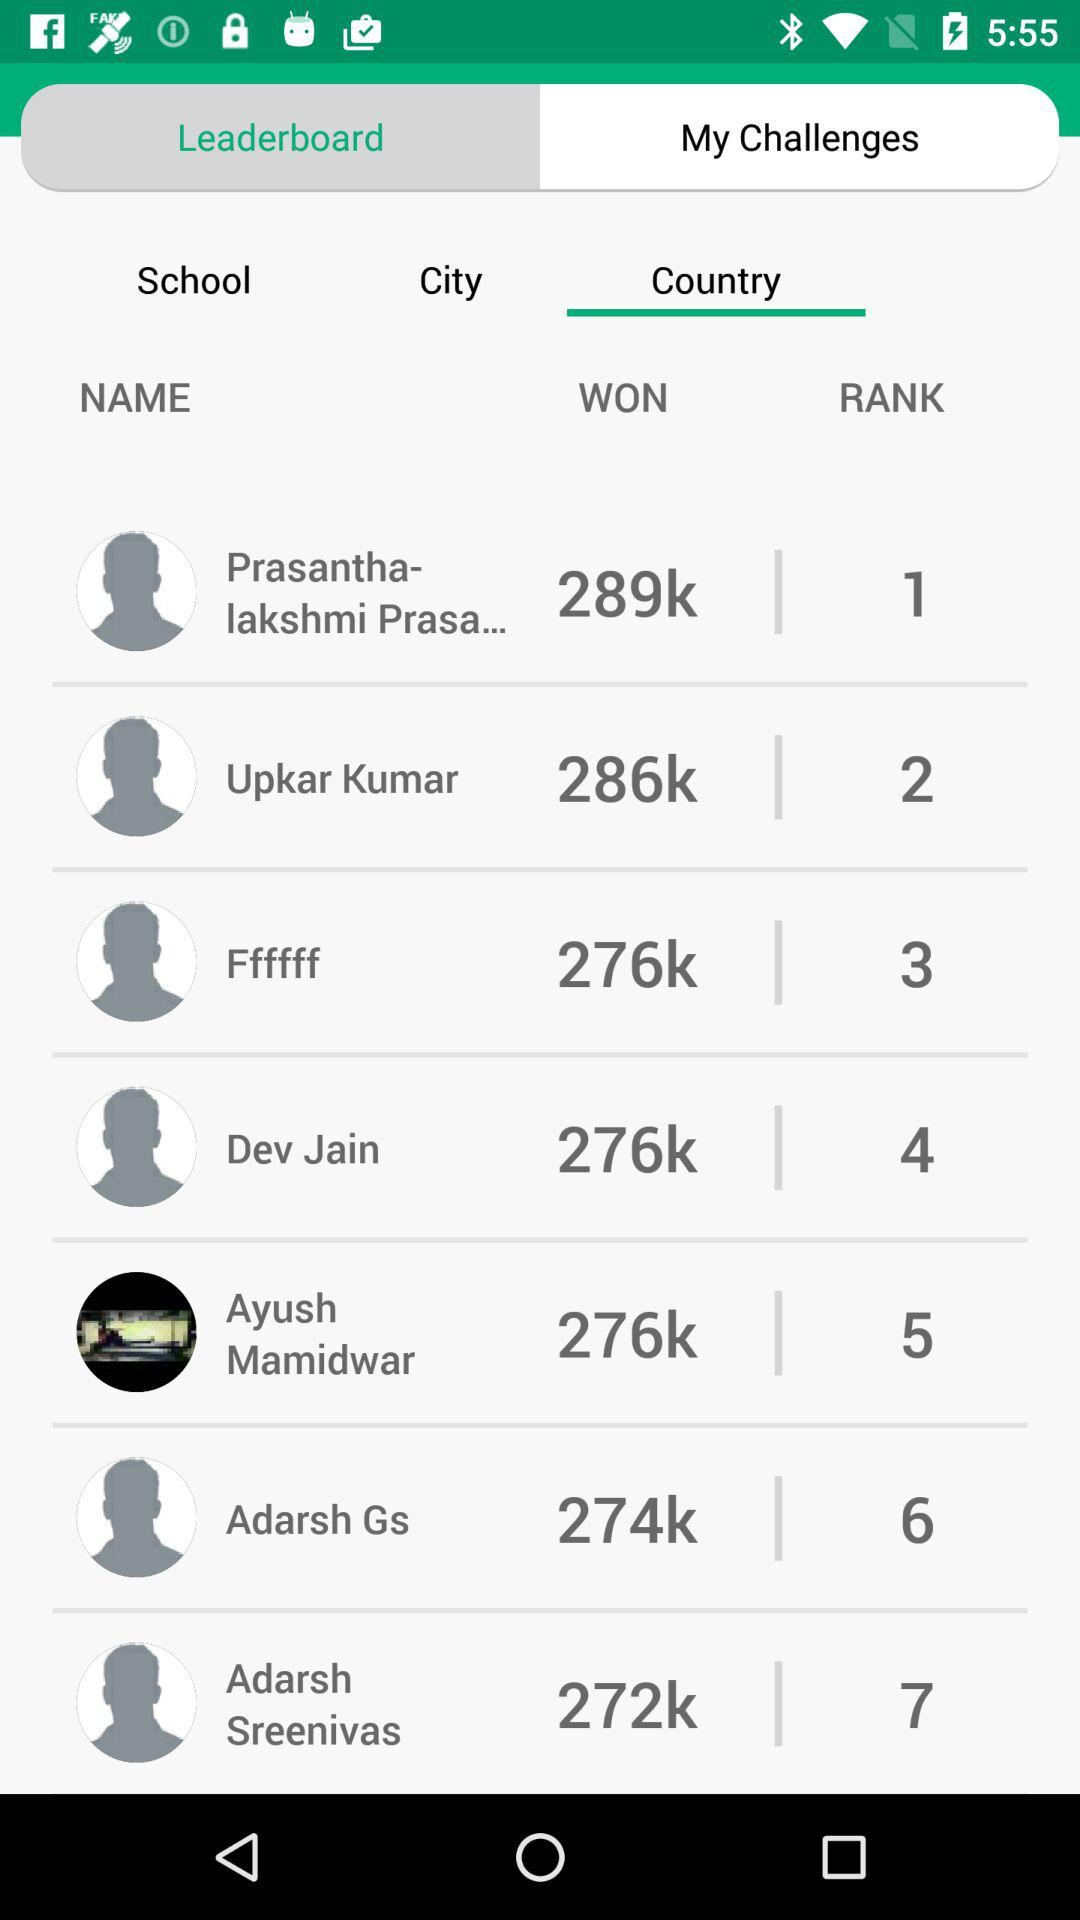Which tab is selected? The selected tabs are "Leaderboard" and "Country". 